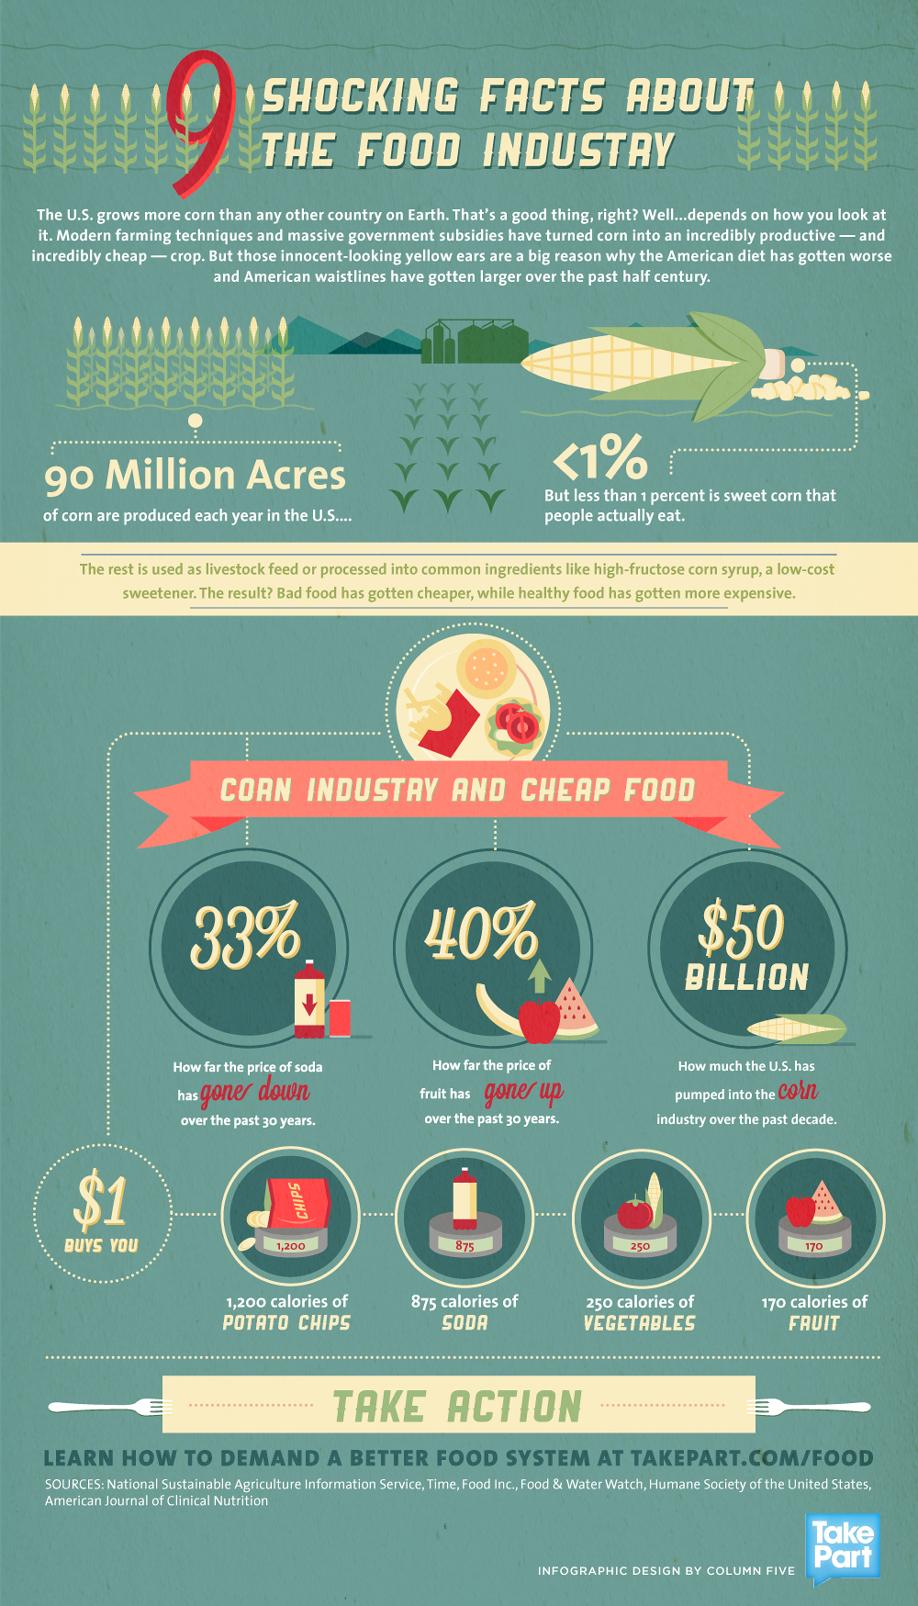Draw attention to some important aspects in this diagram. Over the past decade, the United States has spent approximately $50 BILLION on the corn industry. Over the past 30 years, there has been a significant increase of 40% in the price of fruits in the United States. In the United States, soda has seen a 33% decrease in price over the past 30 years. 